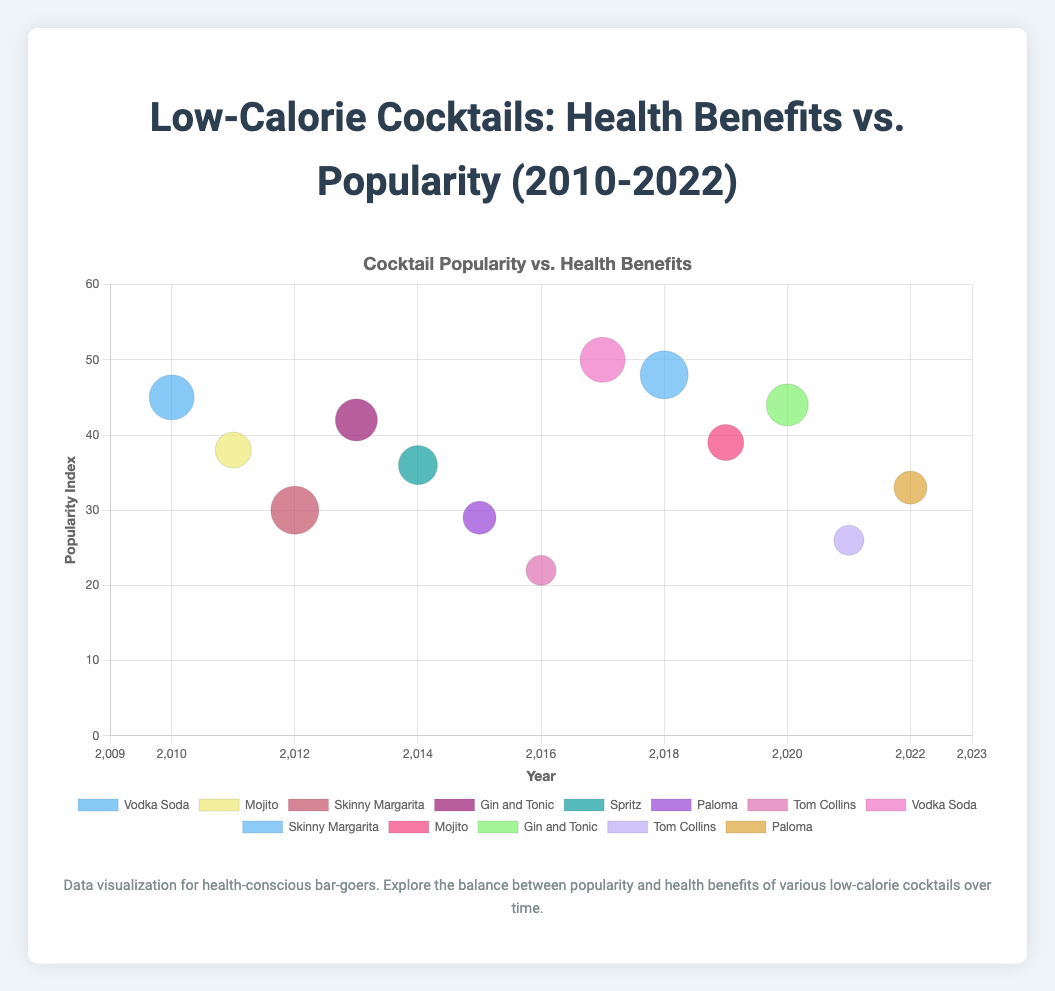What was the popularity index of Vodka Soda in 2017? We look at the bubble associated with 2017 and Vodka Soda, which shows the popularity index at around 50.
Answer: 50 Which cocktail had the highest popularity in 2018? Identify the bubbles from 2018, then check the popularity indexes. The Skinny Margarita bubble has the highest position on the y-axis.
Answer: Skinny Margarita Compare the healthiness score of Vodka Soda in 2010 and 2017. Which year had a higher score? Look at the size of the bubbles for Vodka Soda in 2010 and 2017. Both appear to have similar sizes, indicating a healthiness score of 7.5 for both.
Answer: Both years are equal Does the Mojito have a higher or lower healthiness score than the Gin and Tonic in 2019? Observe the size of the bubbles for Mojito in 2019 and Gin and Tonic in 2020. The Gin and Tonic bubble is larger, indicating a higher healthiness score.
Answer: Lower What's the average popularity index of Tom Collins over the years presented? Sum the popularity indexes for Tom Collins over the presented years: (22 + 26) = 48. Divide by the number of years (2).
Answer: 24 How does the popularity of Skinny Margarita in 2018 compare to 2012? Check the bubbles for Skinny Margarita in 2012 and 2018. The 2018 bubble is higher, indicating a higher popularity index.
Answer: Higher in 2018 What is the trend in the popularity index of Paloma from 2015 to 2022? Identify the bubbles for Paloma in 2015 and 2022. The 2022 bubble is higher, indicating an increase in popularity.
Answer: Increasing Which cocktail has the smallest healthiness score in 2015? Look for the smallest bubble in 2015. The Paloma bubble is the smallest, indicating the lowest healthiness score.
Answer: Paloma What is the combined popularity index of all cocktails in 2013 and 2020? Identify the bubbles for 2013 (42) and 2020 (44), then sum them: 42 + 44 = 86.
Answer: 86 